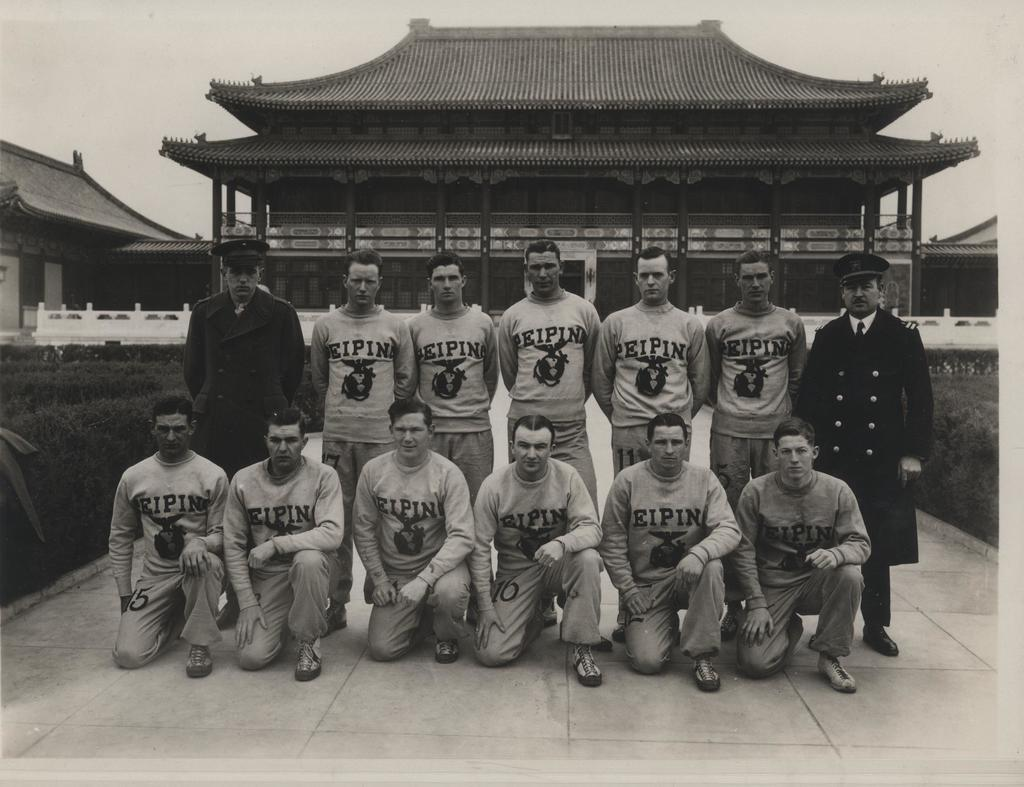<image>
Provide a brief description of the given image. Team getting their picture taken in Japan, their jerseys say PeiPin. 